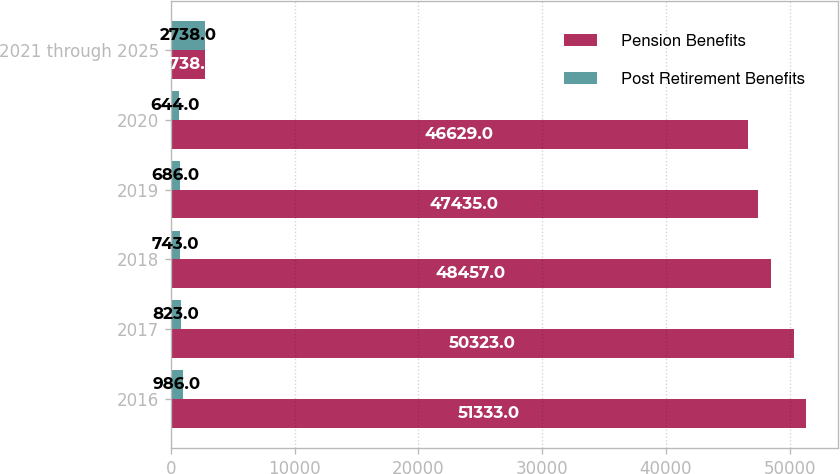Convert chart. <chart><loc_0><loc_0><loc_500><loc_500><stacked_bar_chart><ecel><fcel>2016<fcel>2017<fcel>2018<fcel>2019<fcel>2020<fcel>2021 through 2025<nl><fcel>Pension Benefits<fcel>51333<fcel>50323<fcel>48457<fcel>47435<fcel>46629<fcel>2738<nl><fcel>Post Retirement Benefits<fcel>986<fcel>823<fcel>743<fcel>686<fcel>644<fcel>2738<nl></chart> 